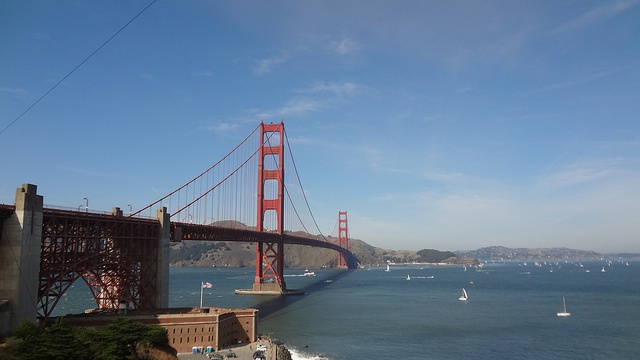Describe the objects in this image and their specific colors. I can see boat in gray, darkgray, and lightgray tones, boat in gray, lightgray, and darkgray tones, boat in gray, darkgray, and lightgray tones, boat in gray and darkgray tones, and boat in gray, navy, and darkblue tones in this image. 